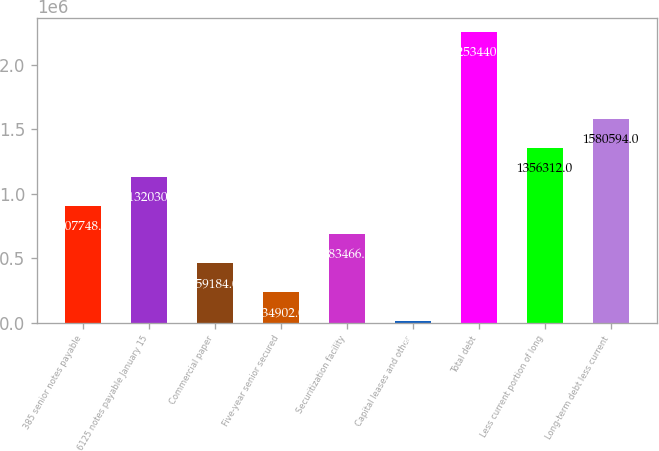Convert chart. <chart><loc_0><loc_0><loc_500><loc_500><bar_chart><fcel>385 senior notes payable<fcel>6125 notes payable January 15<fcel>Commercial paper<fcel>Five-year senior secured<fcel>Securitization facility<fcel>Capital leases and other<fcel>Total debt<fcel>Less current portion of long<fcel>Long-term debt less current<nl><fcel>907748<fcel>1.13203e+06<fcel>459184<fcel>234902<fcel>683466<fcel>10620<fcel>2.25344e+06<fcel>1.35631e+06<fcel>1.58059e+06<nl></chart> 